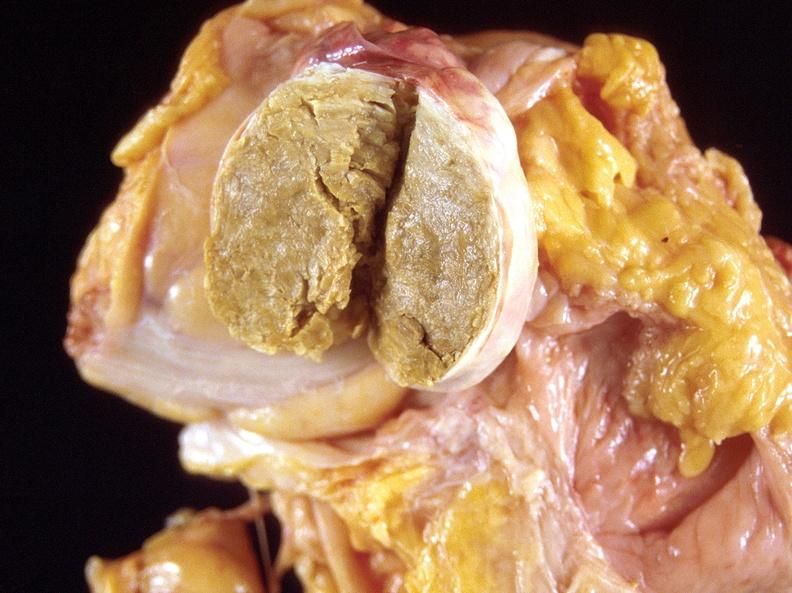where does this part belong to?
Answer the question using a single word or phrase. Female reproductive system 